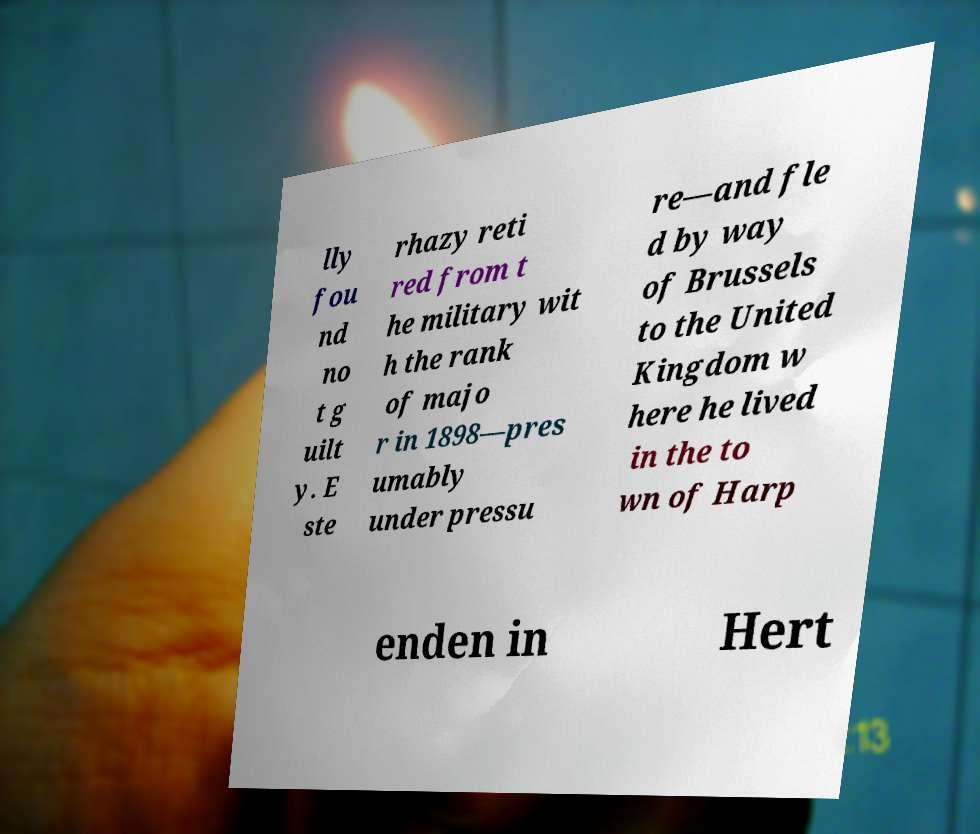What messages or text are displayed in this image? I need them in a readable, typed format. lly fou nd no t g uilt y. E ste rhazy reti red from t he military wit h the rank of majo r in 1898—pres umably under pressu re—and fle d by way of Brussels to the United Kingdom w here he lived in the to wn of Harp enden in Hert 